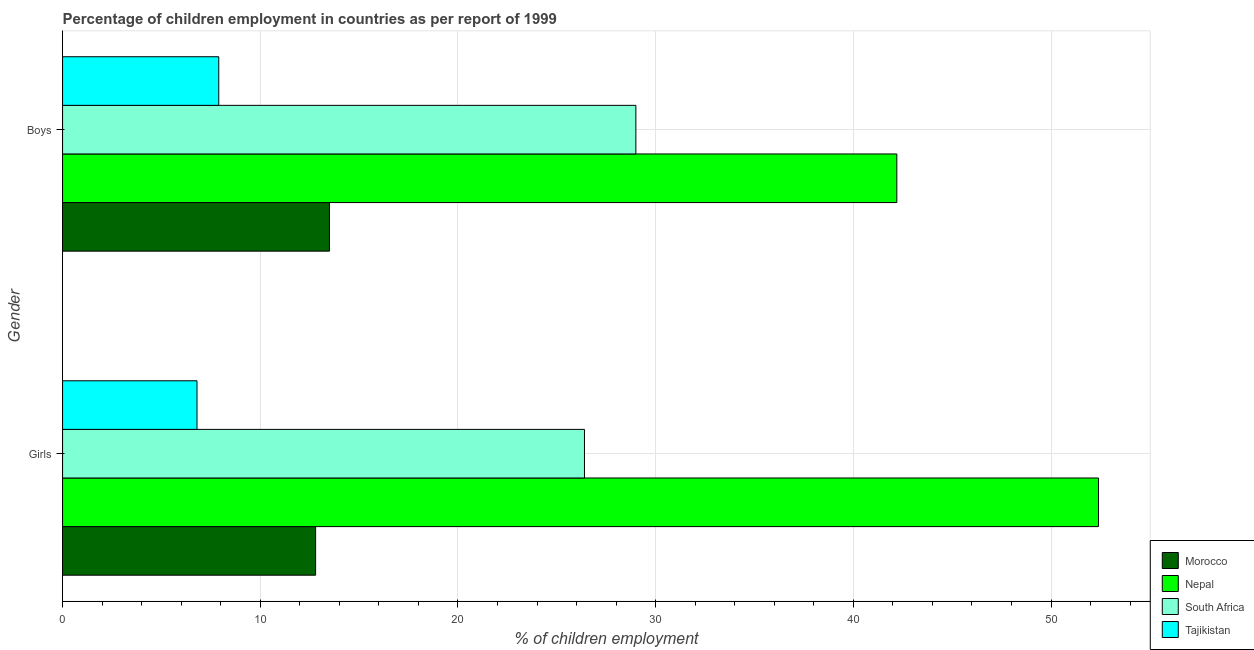How many bars are there on the 1st tick from the bottom?
Your answer should be very brief. 4. What is the label of the 1st group of bars from the top?
Provide a succinct answer. Boys. What is the percentage of employed boys in Nepal?
Give a very brief answer. 42.2. Across all countries, what is the maximum percentage of employed boys?
Ensure brevity in your answer.  42.2. Across all countries, what is the minimum percentage of employed girls?
Offer a very short reply. 6.8. In which country was the percentage of employed girls maximum?
Make the answer very short. Nepal. In which country was the percentage of employed girls minimum?
Provide a succinct answer. Tajikistan. What is the total percentage of employed boys in the graph?
Provide a succinct answer. 92.6. What is the difference between the percentage of employed girls in Tajikistan and that in Nepal?
Your answer should be compact. -45.6. What is the difference between the percentage of employed boys in Nepal and the percentage of employed girls in South Africa?
Offer a very short reply. 15.8. What is the average percentage of employed boys per country?
Give a very brief answer. 23.15. What is the difference between the percentage of employed boys and percentage of employed girls in Nepal?
Your answer should be very brief. -10.2. What is the ratio of the percentage of employed girls in Nepal to that in South Africa?
Provide a succinct answer. 1.98. In how many countries, is the percentage of employed girls greater than the average percentage of employed girls taken over all countries?
Keep it short and to the point. 2. What does the 3rd bar from the top in Girls represents?
Provide a succinct answer. Nepal. What does the 1st bar from the bottom in Boys represents?
Your answer should be very brief. Morocco. What is the difference between two consecutive major ticks on the X-axis?
Your answer should be compact. 10. Does the graph contain any zero values?
Give a very brief answer. No. Where does the legend appear in the graph?
Ensure brevity in your answer.  Bottom right. How many legend labels are there?
Your answer should be compact. 4. What is the title of the graph?
Your answer should be compact. Percentage of children employment in countries as per report of 1999. What is the label or title of the X-axis?
Make the answer very short. % of children employment. What is the % of children employment in Morocco in Girls?
Ensure brevity in your answer.  12.8. What is the % of children employment of Nepal in Girls?
Give a very brief answer. 52.4. What is the % of children employment of South Africa in Girls?
Your response must be concise. 26.4. What is the % of children employment in Tajikistan in Girls?
Ensure brevity in your answer.  6.8. What is the % of children employment of Morocco in Boys?
Provide a short and direct response. 13.5. What is the % of children employment of Nepal in Boys?
Make the answer very short. 42.2. What is the % of children employment in South Africa in Boys?
Give a very brief answer. 29. Across all Gender, what is the maximum % of children employment in Nepal?
Offer a terse response. 52.4. Across all Gender, what is the maximum % of children employment of South Africa?
Offer a terse response. 29. Across all Gender, what is the maximum % of children employment in Tajikistan?
Your answer should be compact. 7.9. Across all Gender, what is the minimum % of children employment in Nepal?
Your response must be concise. 42.2. Across all Gender, what is the minimum % of children employment of South Africa?
Offer a very short reply. 26.4. Across all Gender, what is the minimum % of children employment of Tajikistan?
Keep it short and to the point. 6.8. What is the total % of children employment of Morocco in the graph?
Give a very brief answer. 26.3. What is the total % of children employment in Nepal in the graph?
Provide a succinct answer. 94.6. What is the total % of children employment in South Africa in the graph?
Your answer should be compact. 55.4. What is the difference between the % of children employment in Morocco in Girls and that in Boys?
Provide a succinct answer. -0.7. What is the difference between the % of children employment in South Africa in Girls and that in Boys?
Offer a terse response. -2.6. What is the difference between the % of children employment of Tajikistan in Girls and that in Boys?
Provide a succinct answer. -1.1. What is the difference between the % of children employment of Morocco in Girls and the % of children employment of Nepal in Boys?
Your answer should be very brief. -29.4. What is the difference between the % of children employment in Morocco in Girls and the % of children employment in South Africa in Boys?
Provide a short and direct response. -16.2. What is the difference between the % of children employment in Nepal in Girls and the % of children employment in South Africa in Boys?
Provide a short and direct response. 23.4. What is the difference between the % of children employment of Nepal in Girls and the % of children employment of Tajikistan in Boys?
Your answer should be very brief. 44.5. What is the average % of children employment of Morocco per Gender?
Ensure brevity in your answer.  13.15. What is the average % of children employment of Nepal per Gender?
Your response must be concise. 47.3. What is the average % of children employment in South Africa per Gender?
Offer a terse response. 27.7. What is the average % of children employment in Tajikistan per Gender?
Ensure brevity in your answer.  7.35. What is the difference between the % of children employment of Morocco and % of children employment of Nepal in Girls?
Provide a short and direct response. -39.6. What is the difference between the % of children employment of Morocco and % of children employment of Tajikistan in Girls?
Provide a succinct answer. 6. What is the difference between the % of children employment in Nepal and % of children employment in Tajikistan in Girls?
Your response must be concise. 45.6. What is the difference between the % of children employment in South Africa and % of children employment in Tajikistan in Girls?
Offer a very short reply. 19.6. What is the difference between the % of children employment in Morocco and % of children employment in Nepal in Boys?
Offer a terse response. -28.7. What is the difference between the % of children employment of Morocco and % of children employment of South Africa in Boys?
Ensure brevity in your answer.  -15.5. What is the difference between the % of children employment of Nepal and % of children employment of South Africa in Boys?
Your answer should be compact. 13.2. What is the difference between the % of children employment of Nepal and % of children employment of Tajikistan in Boys?
Your response must be concise. 34.3. What is the difference between the % of children employment of South Africa and % of children employment of Tajikistan in Boys?
Your answer should be compact. 21.1. What is the ratio of the % of children employment of Morocco in Girls to that in Boys?
Provide a succinct answer. 0.95. What is the ratio of the % of children employment in Nepal in Girls to that in Boys?
Offer a terse response. 1.24. What is the ratio of the % of children employment in South Africa in Girls to that in Boys?
Provide a short and direct response. 0.91. What is the ratio of the % of children employment of Tajikistan in Girls to that in Boys?
Offer a terse response. 0.86. What is the difference between the highest and the second highest % of children employment in Morocco?
Your answer should be very brief. 0.7. What is the difference between the highest and the second highest % of children employment of Nepal?
Provide a short and direct response. 10.2. What is the difference between the highest and the second highest % of children employment in Tajikistan?
Your response must be concise. 1.1. What is the difference between the highest and the lowest % of children employment of Nepal?
Ensure brevity in your answer.  10.2. 